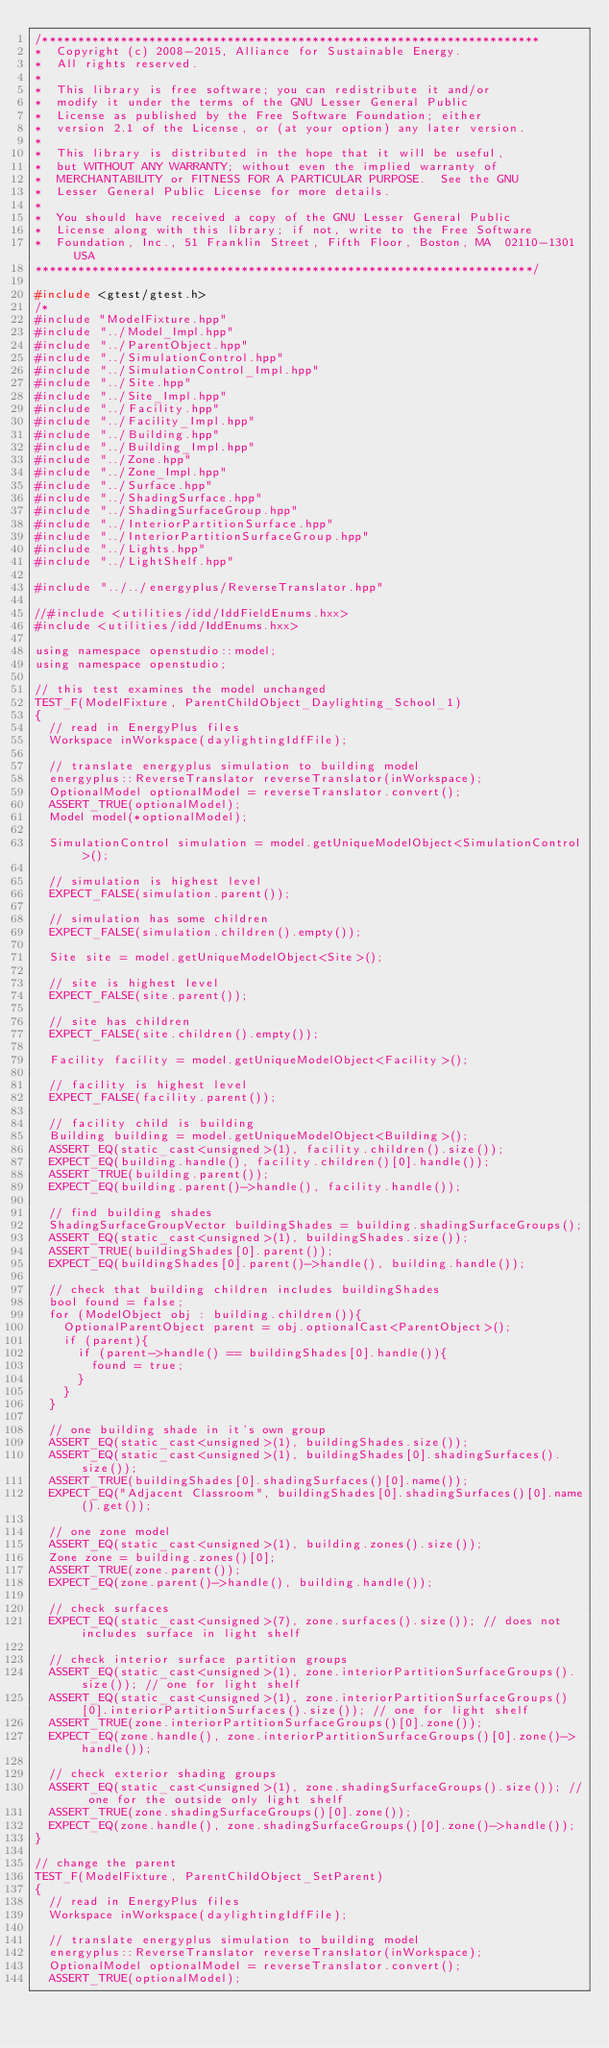<code> <loc_0><loc_0><loc_500><loc_500><_C++_>/**********************************************************************
*  Copyright (c) 2008-2015, Alliance for Sustainable Energy.
*  All rights reserved.
*
*  This library is free software; you can redistribute it and/or
*  modify it under the terms of the GNU Lesser General Public
*  License as published by the Free Software Foundation; either
*  version 2.1 of the License, or (at your option) any later version.
*
*  This library is distributed in the hope that it will be useful,
*  but WITHOUT ANY WARRANTY; without even the implied warranty of
*  MERCHANTABILITY or FITNESS FOR A PARTICULAR PURPOSE.  See the GNU
*  Lesser General Public License for more details.
*
*  You should have received a copy of the GNU Lesser General Public
*  License along with this library; if not, write to the Free Software
*  Foundation, Inc., 51 Franklin Street, Fifth Floor, Boston, MA  02110-1301  USA
**********************************************************************/

#include <gtest/gtest.h>
/*
#include "ModelFixture.hpp"
#include "../Model_Impl.hpp"
#include "../ParentObject.hpp"
#include "../SimulationControl.hpp"
#include "../SimulationControl_Impl.hpp"
#include "../Site.hpp"
#include "../Site_Impl.hpp"
#include "../Facility.hpp"
#include "../Facility_Impl.hpp"
#include "../Building.hpp"
#include "../Building_Impl.hpp"
#include "../Zone.hpp"
#include "../Zone_Impl.hpp"
#include "../Surface.hpp"
#include "../ShadingSurface.hpp"
#include "../ShadingSurfaceGroup.hpp"
#include "../InteriorPartitionSurface.hpp"
#include "../InteriorPartitionSurfaceGroup.hpp"
#include "../Lights.hpp"
#include "../LightShelf.hpp"

#include "../../energyplus/ReverseTranslator.hpp"

//#include <utilities/idd/IddFieldEnums.hxx>
#include <utilities/idd/IddEnums.hxx>

using namespace openstudio::model;
using namespace openstudio;

// this test examines the model unchanged
TEST_F(ModelFixture, ParentChildObject_Daylighting_School_1)
{
  // read in EnergyPlus files
  Workspace inWorkspace(daylightingIdfFile);

  // translate energyplus simulation to building model
  energyplus::ReverseTranslator reverseTranslator(inWorkspace);
  OptionalModel optionalModel = reverseTranslator.convert();
  ASSERT_TRUE(optionalModel);
  Model model(*optionalModel);

  SimulationControl simulation = model.getUniqueModelObject<SimulationControl>();

  // simulation is highest level
  EXPECT_FALSE(simulation.parent());

  // simulation has some children
  EXPECT_FALSE(simulation.children().empty());

  Site site = model.getUniqueModelObject<Site>();

  // site is highest level
  EXPECT_FALSE(site.parent());

  // site has children
  EXPECT_FALSE(site.children().empty());

  Facility facility = model.getUniqueModelObject<Facility>();

  // facility is highest level
  EXPECT_FALSE(facility.parent());

  // facility child is building
  Building building = model.getUniqueModelObject<Building>();
  ASSERT_EQ(static_cast<unsigned>(1), facility.children().size());
  EXPECT_EQ(building.handle(), facility.children()[0].handle());
  ASSERT_TRUE(building.parent());
  EXPECT_EQ(building.parent()->handle(), facility.handle());

  // find building shades
  ShadingSurfaceGroupVector buildingShades = building.shadingSurfaceGroups();
  ASSERT_EQ(static_cast<unsigned>(1), buildingShades.size());
  ASSERT_TRUE(buildingShades[0].parent());
  EXPECT_EQ(buildingShades[0].parent()->handle(), building.handle());

  // check that building children includes buildingShades
  bool found = false;
  for (ModelObject obj : building.children()){
    OptionalParentObject parent = obj.optionalCast<ParentObject>();
    if (parent){
      if (parent->handle() == buildingShades[0].handle()){
        found = true;
      }
    }
  }

  // one building shade in it's own group
  ASSERT_EQ(static_cast<unsigned>(1), buildingShades.size());
  ASSERT_EQ(static_cast<unsigned>(1), buildingShades[0].shadingSurfaces().size());
  ASSERT_TRUE(buildingShades[0].shadingSurfaces()[0].name());
  EXPECT_EQ("Adjacent Classroom", buildingShades[0].shadingSurfaces()[0].name().get());

  // one zone model
  ASSERT_EQ(static_cast<unsigned>(1), building.zones().size());
  Zone zone = building.zones()[0];
  ASSERT_TRUE(zone.parent());
  EXPECT_EQ(zone.parent()->handle(), building.handle());

  // check surfaces
  EXPECT_EQ(static_cast<unsigned>(7), zone.surfaces().size()); // does not includes surface in light shelf

  // check interior surface partition groups
  ASSERT_EQ(static_cast<unsigned>(1), zone.interiorPartitionSurfaceGroups().size()); // one for light shelf
  ASSERT_EQ(static_cast<unsigned>(1), zone.interiorPartitionSurfaceGroups()[0].interiorPartitionSurfaces().size()); // one for light shelf
  ASSERT_TRUE(zone.interiorPartitionSurfaceGroups()[0].zone());
  EXPECT_EQ(zone.handle(), zone.interiorPartitionSurfaceGroups()[0].zone()->handle());

  // check exterior shading groups
  ASSERT_EQ(static_cast<unsigned>(1), zone.shadingSurfaceGroups().size()); // one for the outside only light shelf
  ASSERT_TRUE(zone.shadingSurfaceGroups()[0].zone());
  EXPECT_EQ(zone.handle(), zone.shadingSurfaceGroups()[0].zone()->handle());
}

// change the parent
TEST_F(ModelFixture, ParentChildObject_SetParent)
{
  // read in EnergyPlus files
  Workspace inWorkspace(daylightingIdfFile);

  // translate energyplus simulation to building model
  energyplus::ReverseTranslator reverseTranslator(inWorkspace);
  OptionalModel optionalModel = reverseTranslator.convert();
  ASSERT_TRUE(optionalModel);</code> 